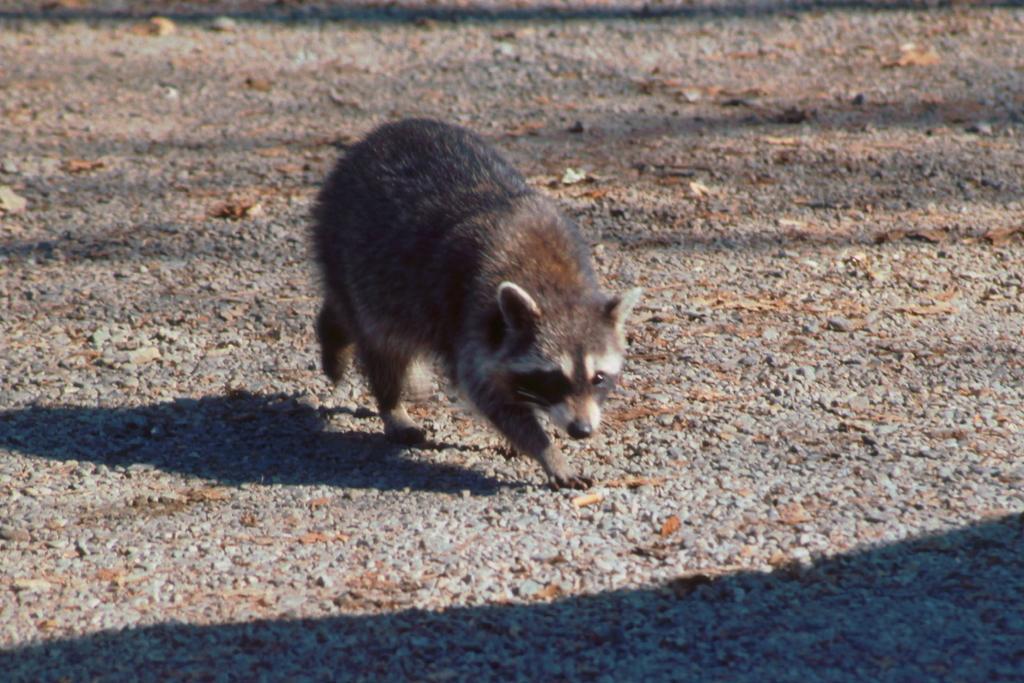Can you describe this image briefly? In this picture, we see a raccoon. At the bottom, we see the pavement and the dry leaves. On the left side, we see the shadow of the raccoon. 